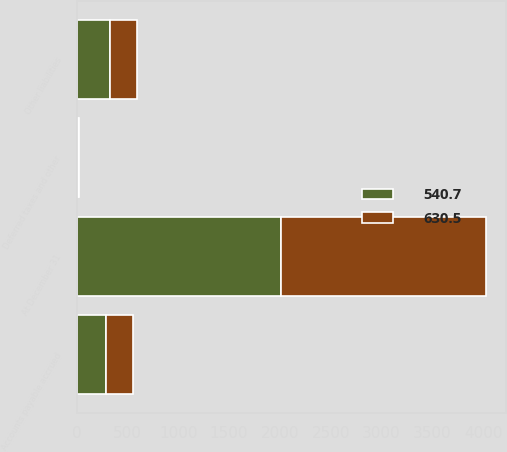<chart> <loc_0><loc_0><loc_500><loc_500><stacked_bar_chart><ecel><fcel>At December 31<fcel>Accounts payable accrued<fcel>Other liabilities<fcel>Deferred taxes and other<nl><fcel>540.7<fcel>2013<fcel>291.7<fcel>327.5<fcel>11.3<nl><fcel>630.5<fcel>2012<fcel>265.2<fcel>265.8<fcel>9.7<nl></chart> 